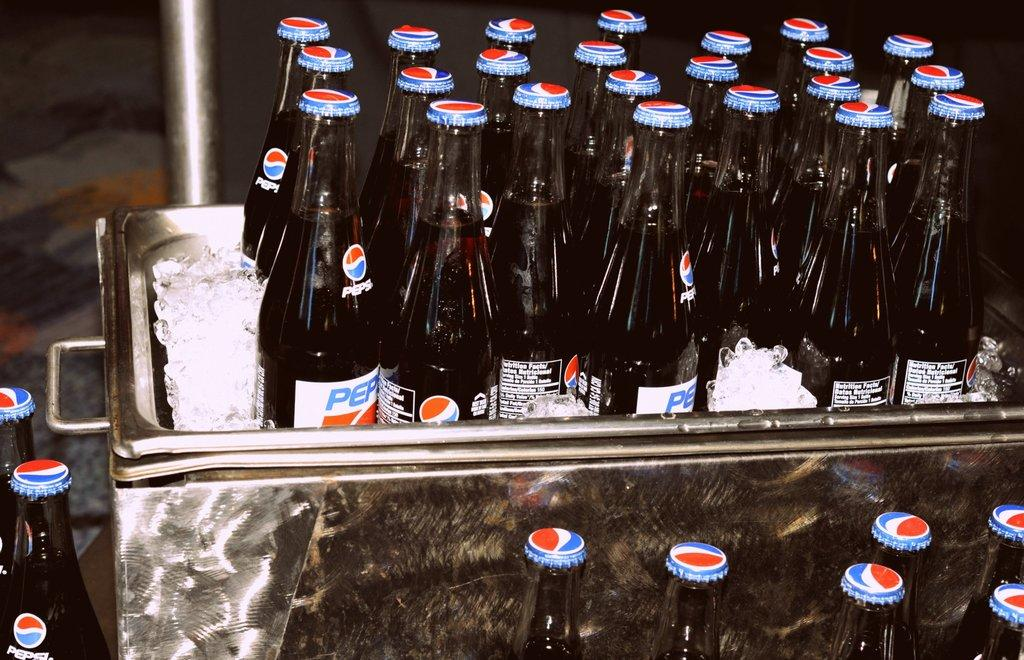<image>
Give a short and clear explanation of the subsequent image. A number of bottles of old style Pepsi. 